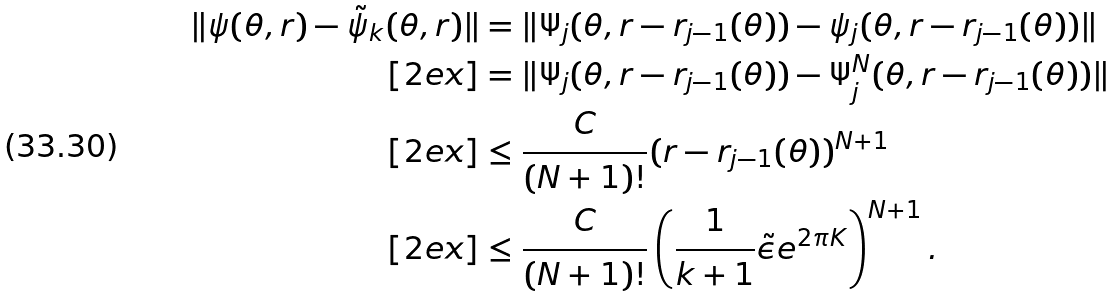Convert formula to latex. <formula><loc_0><loc_0><loc_500><loc_500>\| \psi ( \theta , r ) - \tilde { \psi } _ { k } ( \theta , r ) \| & = \| \Psi _ { j } ( \theta , r - r _ { j - 1 } ( \theta ) ) - \psi _ { j } ( \theta , r - r _ { j - 1 } ( \theta ) ) \| \\ [ 2 e x ] & = \| \Psi _ { j } ( \theta , r - r _ { j - 1 } ( \theta ) ) - \Psi ^ { N } _ { j } ( \theta , r - r _ { j - 1 } ( \theta ) ) \| \\ [ 2 e x ] & \leq \frac { C } { ( N + 1 ) ! } ( r - r _ { j - 1 } ( \theta ) ) ^ { N + 1 } \\ [ 2 e x ] & \leq \frac { C } { ( N + 1 ) ! } \left ( \frac { 1 } { k + 1 } \tilde { \epsilon } e ^ { 2 \pi K } \right ) ^ { N + 1 } .</formula> 